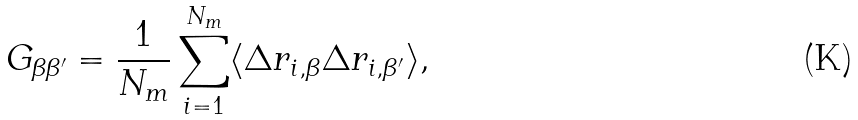<formula> <loc_0><loc_0><loc_500><loc_500>G _ { \beta \beta ^ { \prime } } = \frac { 1 } { N _ { m } } \sum ^ { N _ { m } } _ { i = 1 } \langle \Delta r _ { i , \beta } \Delta r _ { i , \beta ^ { \prime } } \rangle ,</formula> 